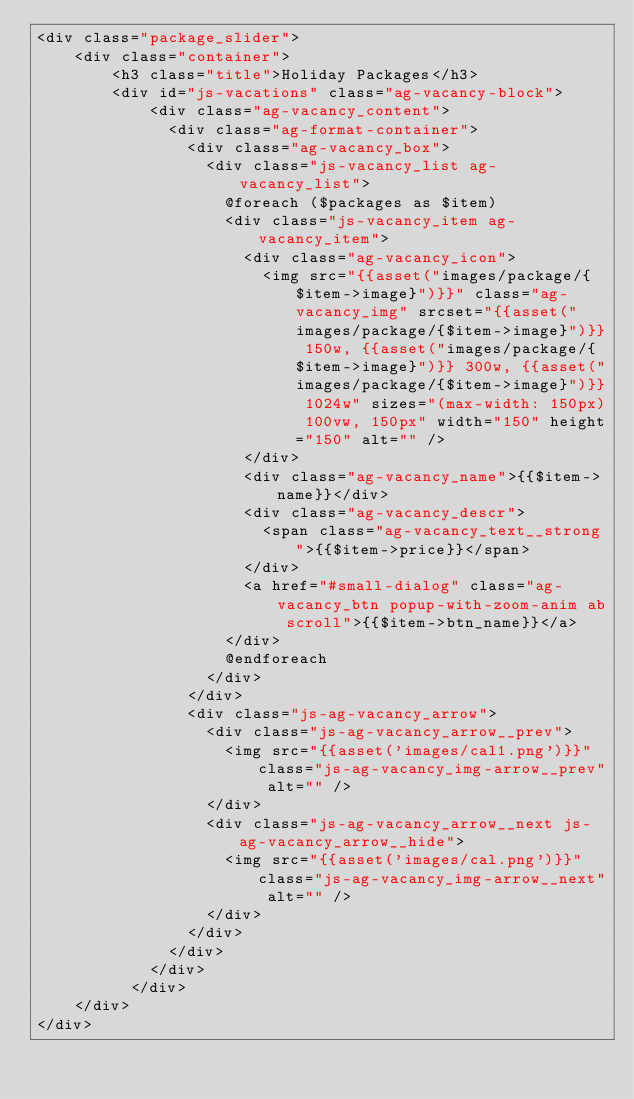<code> <loc_0><loc_0><loc_500><loc_500><_PHP_><div class="package_slider">
    <div class="container">
        <h3 class="title">Holiday Packages</h3>
        <div id="js-vacations" class="ag-vacancy-block">
            <div class="ag-vacancy_content">
              <div class="ag-format-container">
                <div class="ag-vacancy_box">
                  <div class="js-vacancy_list ag-vacancy_list">
                    @foreach ($packages as $item)
                    <div class="js-vacancy_item ag-vacancy_item">
                      <div class="ag-vacancy_icon">
                        <img src="{{asset("images/package/{$item->image}")}}" class="ag-vacancy_img" srcset="{{asset("images/package/{$item->image}")}} 150w, {{asset("images/package/{$item->image}")}} 300w, {{asset("images/package/{$item->image}")}} 1024w" sizes="(max-width: 150px) 100vw, 150px" width="150" height="150" alt="" />
                      </div>
                      <div class="ag-vacancy_name">{{$item->name}}</div>
                      <div class="ag-vacancy_descr">
                        <span class="ag-vacancy_text__strong">{{$item->price}}</span>
                      </div>
                      <a href="#small-dialog" class="ag-vacancy_btn popup-with-zoom-anim ab scroll">{{$item->btn_name}}</a>
                    </div>
                    @endforeach
                  </div>
                </div>
                <div class="js-ag-vacancy_arrow">
                  <div class="js-ag-vacancy_arrow__prev">
                    <img src="{{asset('images/cal1.png')}}" class="js-ag-vacancy_img-arrow__prev" alt="" />
                  </div>
                  <div class="js-ag-vacancy_arrow__next js-ag-vacancy_arrow__hide">
                    <img src="{{asset('images/cal.png')}}" class="js-ag-vacancy_img-arrow__next" alt="" />
                  </div>
                </div>
              </div>
            </div>
          </div>
    </div>
</div></code> 